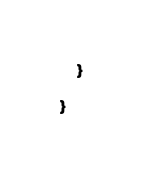<code> <loc_0><loc_0><loc_500><loc_500><_Scala_>    }

}
</code> 